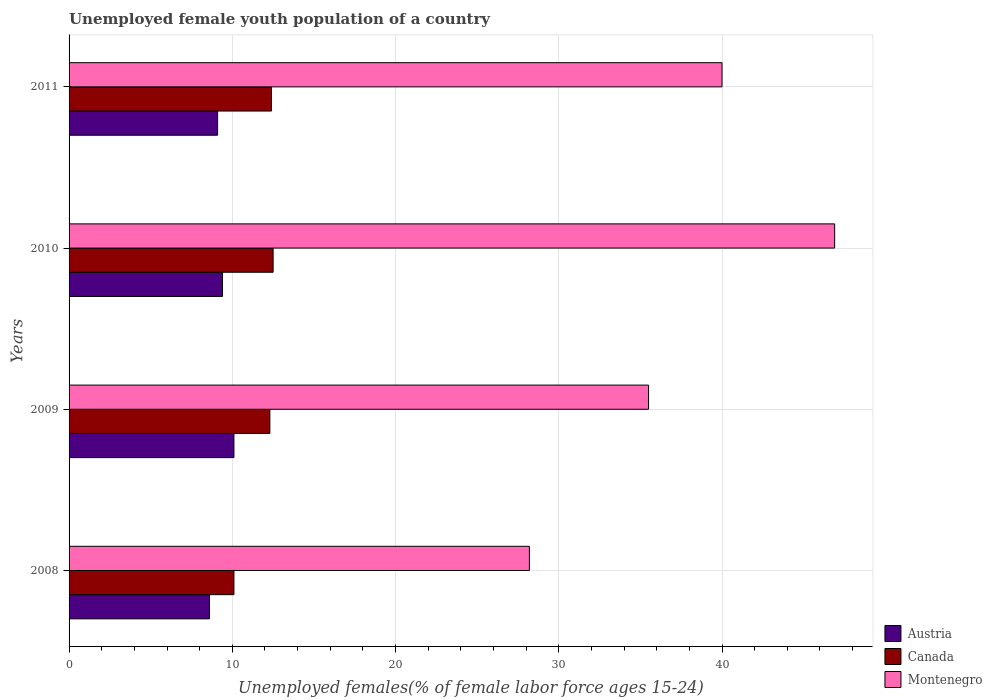How many different coloured bars are there?
Provide a succinct answer. 3. Are the number of bars on each tick of the Y-axis equal?
Keep it short and to the point. Yes. What is the label of the 4th group of bars from the top?
Your response must be concise. 2008. In how many cases, is the number of bars for a given year not equal to the number of legend labels?
Offer a terse response. 0. What is the percentage of unemployed female youth population in Montenegro in 2011?
Your response must be concise. 40. Across all years, what is the maximum percentage of unemployed female youth population in Canada?
Offer a terse response. 12.5. Across all years, what is the minimum percentage of unemployed female youth population in Austria?
Provide a succinct answer. 8.6. In which year was the percentage of unemployed female youth population in Montenegro maximum?
Keep it short and to the point. 2010. What is the total percentage of unemployed female youth population in Canada in the graph?
Make the answer very short. 47.3. What is the difference between the percentage of unemployed female youth population in Montenegro in 2008 and that in 2011?
Ensure brevity in your answer.  -11.8. What is the difference between the percentage of unemployed female youth population in Montenegro in 2010 and the percentage of unemployed female youth population in Austria in 2011?
Offer a very short reply. 37.8. What is the average percentage of unemployed female youth population in Canada per year?
Your answer should be very brief. 11.83. In the year 2009, what is the difference between the percentage of unemployed female youth population in Austria and percentage of unemployed female youth population in Canada?
Ensure brevity in your answer.  -2.2. In how many years, is the percentage of unemployed female youth population in Austria greater than 26 %?
Provide a short and direct response. 0. What is the ratio of the percentage of unemployed female youth population in Canada in 2008 to that in 2010?
Offer a terse response. 0.81. Is the difference between the percentage of unemployed female youth population in Austria in 2008 and 2009 greater than the difference between the percentage of unemployed female youth population in Canada in 2008 and 2009?
Offer a terse response. Yes. What is the difference between the highest and the second highest percentage of unemployed female youth population in Austria?
Make the answer very short. 0.7. What is the difference between the highest and the lowest percentage of unemployed female youth population in Austria?
Ensure brevity in your answer.  1.5. Is it the case that in every year, the sum of the percentage of unemployed female youth population in Canada and percentage of unemployed female youth population in Montenegro is greater than the percentage of unemployed female youth population in Austria?
Give a very brief answer. Yes. How many bars are there?
Your response must be concise. 12. How many years are there in the graph?
Ensure brevity in your answer.  4. What is the difference between two consecutive major ticks on the X-axis?
Provide a short and direct response. 10. Does the graph contain grids?
Keep it short and to the point. Yes. What is the title of the graph?
Provide a short and direct response. Unemployed female youth population of a country. What is the label or title of the X-axis?
Give a very brief answer. Unemployed females(% of female labor force ages 15-24). What is the Unemployed females(% of female labor force ages 15-24) in Austria in 2008?
Provide a short and direct response. 8.6. What is the Unemployed females(% of female labor force ages 15-24) of Canada in 2008?
Your answer should be very brief. 10.1. What is the Unemployed females(% of female labor force ages 15-24) in Montenegro in 2008?
Your answer should be compact. 28.2. What is the Unemployed females(% of female labor force ages 15-24) of Austria in 2009?
Make the answer very short. 10.1. What is the Unemployed females(% of female labor force ages 15-24) in Canada in 2009?
Your answer should be very brief. 12.3. What is the Unemployed females(% of female labor force ages 15-24) in Montenegro in 2009?
Provide a succinct answer. 35.5. What is the Unemployed females(% of female labor force ages 15-24) of Austria in 2010?
Your answer should be compact. 9.4. What is the Unemployed females(% of female labor force ages 15-24) in Canada in 2010?
Give a very brief answer. 12.5. What is the Unemployed females(% of female labor force ages 15-24) in Montenegro in 2010?
Provide a short and direct response. 46.9. What is the Unemployed females(% of female labor force ages 15-24) in Austria in 2011?
Your response must be concise. 9.1. What is the Unemployed females(% of female labor force ages 15-24) of Canada in 2011?
Your response must be concise. 12.4. What is the Unemployed females(% of female labor force ages 15-24) in Montenegro in 2011?
Give a very brief answer. 40. Across all years, what is the maximum Unemployed females(% of female labor force ages 15-24) of Austria?
Provide a succinct answer. 10.1. Across all years, what is the maximum Unemployed females(% of female labor force ages 15-24) in Canada?
Ensure brevity in your answer.  12.5. Across all years, what is the maximum Unemployed females(% of female labor force ages 15-24) in Montenegro?
Your answer should be compact. 46.9. Across all years, what is the minimum Unemployed females(% of female labor force ages 15-24) in Austria?
Your response must be concise. 8.6. Across all years, what is the minimum Unemployed females(% of female labor force ages 15-24) in Canada?
Your answer should be compact. 10.1. Across all years, what is the minimum Unemployed females(% of female labor force ages 15-24) of Montenegro?
Offer a very short reply. 28.2. What is the total Unemployed females(% of female labor force ages 15-24) of Austria in the graph?
Provide a succinct answer. 37.2. What is the total Unemployed females(% of female labor force ages 15-24) in Canada in the graph?
Offer a very short reply. 47.3. What is the total Unemployed females(% of female labor force ages 15-24) in Montenegro in the graph?
Provide a succinct answer. 150.6. What is the difference between the Unemployed females(% of female labor force ages 15-24) of Austria in 2008 and that in 2010?
Make the answer very short. -0.8. What is the difference between the Unemployed females(% of female labor force ages 15-24) in Montenegro in 2008 and that in 2010?
Give a very brief answer. -18.7. What is the difference between the Unemployed females(% of female labor force ages 15-24) of Canada in 2009 and that in 2011?
Provide a short and direct response. -0.1. What is the difference between the Unemployed females(% of female labor force ages 15-24) of Austria in 2010 and that in 2011?
Your answer should be very brief. 0.3. What is the difference between the Unemployed females(% of female labor force ages 15-24) of Austria in 2008 and the Unemployed females(% of female labor force ages 15-24) of Canada in 2009?
Provide a short and direct response. -3.7. What is the difference between the Unemployed females(% of female labor force ages 15-24) in Austria in 2008 and the Unemployed females(% of female labor force ages 15-24) in Montenegro in 2009?
Ensure brevity in your answer.  -26.9. What is the difference between the Unemployed females(% of female labor force ages 15-24) of Canada in 2008 and the Unemployed females(% of female labor force ages 15-24) of Montenegro in 2009?
Provide a succinct answer. -25.4. What is the difference between the Unemployed females(% of female labor force ages 15-24) of Austria in 2008 and the Unemployed females(% of female labor force ages 15-24) of Montenegro in 2010?
Your answer should be very brief. -38.3. What is the difference between the Unemployed females(% of female labor force ages 15-24) in Canada in 2008 and the Unemployed females(% of female labor force ages 15-24) in Montenegro in 2010?
Ensure brevity in your answer.  -36.8. What is the difference between the Unemployed females(% of female labor force ages 15-24) of Austria in 2008 and the Unemployed females(% of female labor force ages 15-24) of Canada in 2011?
Provide a succinct answer. -3.8. What is the difference between the Unemployed females(% of female labor force ages 15-24) of Austria in 2008 and the Unemployed females(% of female labor force ages 15-24) of Montenegro in 2011?
Provide a short and direct response. -31.4. What is the difference between the Unemployed females(% of female labor force ages 15-24) in Canada in 2008 and the Unemployed females(% of female labor force ages 15-24) in Montenegro in 2011?
Give a very brief answer. -29.9. What is the difference between the Unemployed females(% of female labor force ages 15-24) in Austria in 2009 and the Unemployed females(% of female labor force ages 15-24) in Canada in 2010?
Provide a short and direct response. -2.4. What is the difference between the Unemployed females(% of female labor force ages 15-24) of Austria in 2009 and the Unemployed females(% of female labor force ages 15-24) of Montenegro in 2010?
Make the answer very short. -36.8. What is the difference between the Unemployed females(% of female labor force ages 15-24) in Canada in 2009 and the Unemployed females(% of female labor force ages 15-24) in Montenegro in 2010?
Ensure brevity in your answer.  -34.6. What is the difference between the Unemployed females(% of female labor force ages 15-24) of Austria in 2009 and the Unemployed females(% of female labor force ages 15-24) of Montenegro in 2011?
Your answer should be very brief. -29.9. What is the difference between the Unemployed females(% of female labor force ages 15-24) of Canada in 2009 and the Unemployed females(% of female labor force ages 15-24) of Montenegro in 2011?
Provide a short and direct response. -27.7. What is the difference between the Unemployed females(% of female labor force ages 15-24) in Austria in 2010 and the Unemployed females(% of female labor force ages 15-24) in Canada in 2011?
Provide a short and direct response. -3. What is the difference between the Unemployed females(% of female labor force ages 15-24) of Austria in 2010 and the Unemployed females(% of female labor force ages 15-24) of Montenegro in 2011?
Provide a succinct answer. -30.6. What is the difference between the Unemployed females(% of female labor force ages 15-24) of Canada in 2010 and the Unemployed females(% of female labor force ages 15-24) of Montenegro in 2011?
Offer a very short reply. -27.5. What is the average Unemployed females(% of female labor force ages 15-24) of Austria per year?
Give a very brief answer. 9.3. What is the average Unemployed females(% of female labor force ages 15-24) in Canada per year?
Keep it short and to the point. 11.82. What is the average Unemployed females(% of female labor force ages 15-24) in Montenegro per year?
Provide a short and direct response. 37.65. In the year 2008, what is the difference between the Unemployed females(% of female labor force ages 15-24) in Austria and Unemployed females(% of female labor force ages 15-24) in Montenegro?
Offer a terse response. -19.6. In the year 2008, what is the difference between the Unemployed females(% of female labor force ages 15-24) in Canada and Unemployed females(% of female labor force ages 15-24) in Montenegro?
Provide a short and direct response. -18.1. In the year 2009, what is the difference between the Unemployed females(% of female labor force ages 15-24) of Austria and Unemployed females(% of female labor force ages 15-24) of Canada?
Give a very brief answer. -2.2. In the year 2009, what is the difference between the Unemployed females(% of female labor force ages 15-24) of Austria and Unemployed females(% of female labor force ages 15-24) of Montenegro?
Your answer should be very brief. -25.4. In the year 2009, what is the difference between the Unemployed females(% of female labor force ages 15-24) of Canada and Unemployed females(% of female labor force ages 15-24) of Montenegro?
Provide a succinct answer. -23.2. In the year 2010, what is the difference between the Unemployed females(% of female labor force ages 15-24) in Austria and Unemployed females(% of female labor force ages 15-24) in Canada?
Your answer should be very brief. -3.1. In the year 2010, what is the difference between the Unemployed females(% of female labor force ages 15-24) in Austria and Unemployed females(% of female labor force ages 15-24) in Montenegro?
Your answer should be very brief. -37.5. In the year 2010, what is the difference between the Unemployed females(% of female labor force ages 15-24) in Canada and Unemployed females(% of female labor force ages 15-24) in Montenegro?
Give a very brief answer. -34.4. In the year 2011, what is the difference between the Unemployed females(% of female labor force ages 15-24) of Austria and Unemployed females(% of female labor force ages 15-24) of Montenegro?
Provide a succinct answer. -30.9. In the year 2011, what is the difference between the Unemployed females(% of female labor force ages 15-24) in Canada and Unemployed females(% of female labor force ages 15-24) in Montenegro?
Ensure brevity in your answer.  -27.6. What is the ratio of the Unemployed females(% of female labor force ages 15-24) of Austria in 2008 to that in 2009?
Your answer should be compact. 0.85. What is the ratio of the Unemployed females(% of female labor force ages 15-24) in Canada in 2008 to that in 2009?
Keep it short and to the point. 0.82. What is the ratio of the Unemployed females(% of female labor force ages 15-24) of Montenegro in 2008 to that in 2009?
Offer a terse response. 0.79. What is the ratio of the Unemployed females(% of female labor force ages 15-24) in Austria in 2008 to that in 2010?
Offer a very short reply. 0.91. What is the ratio of the Unemployed females(% of female labor force ages 15-24) of Canada in 2008 to that in 2010?
Your answer should be compact. 0.81. What is the ratio of the Unemployed females(% of female labor force ages 15-24) of Montenegro in 2008 to that in 2010?
Offer a very short reply. 0.6. What is the ratio of the Unemployed females(% of female labor force ages 15-24) in Austria in 2008 to that in 2011?
Make the answer very short. 0.95. What is the ratio of the Unemployed females(% of female labor force ages 15-24) of Canada in 2008 to that in 2011?
Your response must be concise. 0.81. What is the ratio of the Unemployed females(% of female labor force ages 15-24) of Montenegro in 2008 to that in 2011?
Your answer should be compact. 0.7. What is the ratio of the Unemployed females(% of female labor force ages 15-24) of Austria in 2009 to that in 2010?
Provide a succinct answer. 1.07. What is the ratio of the Unemployed females(% of female labor force ages 15-24) of Canada in 2009 to that in 2010?
Your response must be concise. 0.98. What is the ratio of the Unemployed females(% of female labor force ages 15-24) of Montenegro in 2009 to that in 2010?
Offer a terse response. 0.76. What is the ratio of the Unemployed females(% of female labor force ages 15-24) of Austria in 2009 to that in 2011?
Your answer should be compact. 1.11. What is the ratio of the Unemployed females(% of female labor force ages 15-24) of Montenegro in 2009 to that in 2011?
Offer a very short reply. 0.89. What is the ratio of the Unemployed females(% of female labor force ages 15-24) in Austria in 2010 to that in 2011?
Ensure brevity in your answer.  1.03. What is the ratio of the Unemployed females(% of female labor force ages 15-24) in Montenegro in 2010 to that in 2011?
Your answer should be compact. 1.17. What is the difference between the highest and the second highest Unemployed females(% of female labor force ages 15-24) in Austria?
Provide a short and direct response. 0.7. What is the difference between the highest and the second highest Unemployed females(% of female labor force ages 15-24) of Canada?
Offer a very short reply. 0.1. What is the difference between the highest and the lowest Unemployed females(% of female labor force ages 15-24) of Canada?
Offer a very short reply. 2.4. 